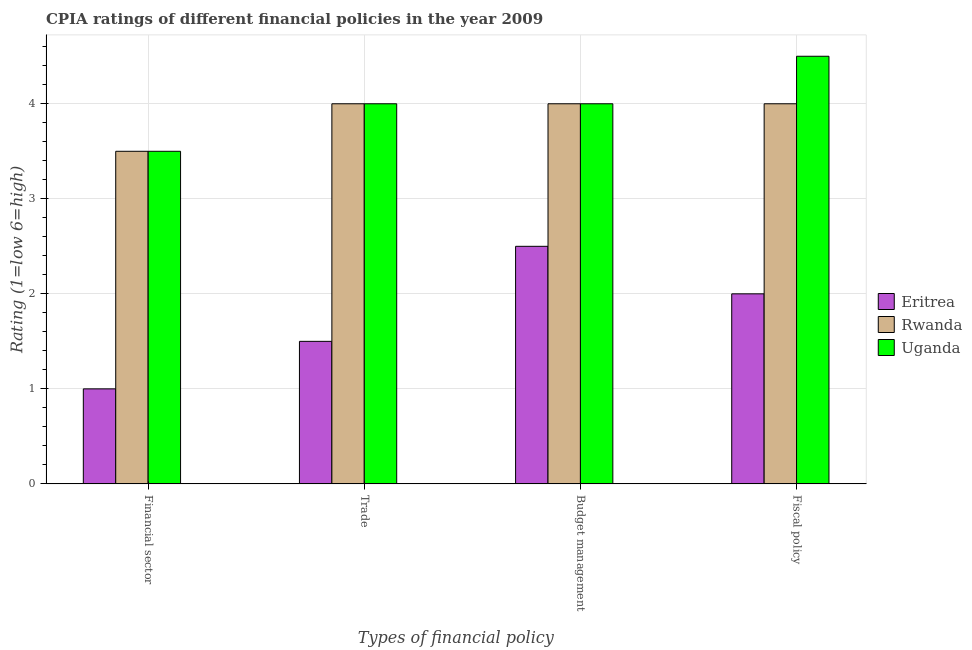How many groups of bars are there?
Give a very brief answer. 4. How many bars are there on the 2nd tick from the left?
Give a very brief answer. 3. What is the label of the 4th group of bars from the left?
Ensure brevity in your answer.  Fiscal policy. Across all countries, what is the maximum cpia rating of budget management?
Give a very brief answer. 4. Across all countries, what is the minimum cpia rating of fiscal policy?
Offer a very short reply. 2. In which country was the cpia rating of trade maximum?
Your response must be concise. Rwanda. In which country was the cpia rating of budget management minimum?
Provide a succinct answer. Eritrea. What is the total cpia rating of trade in the graph?
Provide a succinct answer. 9.5. What is the difference between the cpia rating of budget management in Eritrea and that in Uganda?
Your answer should be compact. -1.5. What is the average cpia rating of financial sector per country?
Your response must be concise. 2.67. In how many countries, is the cpia rating of financial sector greater than 1 ?
Give a very brief answer. 2. What is the ratio of the cpia rating of fiscal policy in Rwanda to that in Uganda?
Offer a terse response. 0.89. Is the cpia rating of budget management in Uganda less than that in Rwanda?
Make the answer very short. No. Is the difference between the cpia rating of budget management in Rwanda and Uganda greater than the difference between the cpia rating of fiscal policy in Rwanda and Uganda?
Ensure brevity in your answer.  Yes. What does the 1st bar from the left in Trade represents?
Your response must be concise. Eritrea. What does the 3rd bar from the right in Trade represents?
Provide a succinct answer. Eritrea. Is it the case that in every country, the sum of the cpia rating of financial sector and cpia rating of trade is greater than the cpia rating of budget management?
Offer a very short reply. No. How many bars are there?
Your answer should be compact. 12. How many countries are there in the graph?
Make the answer very short. 3. What is the difference between two consecutive major ticks on the Y-axis?
Offer a terse response. 1. Are the values on the major ticks of Y-axis written in scientific E-notation?
Make the answer very short. No. Does the graph contain grids?
Provide a short and direct response. Yes. How many legend labels are there?
Keep it short and to the point. 3. How are the legend labels stacked?
Give a very brief answer. Vertical. What is the title of the graph?
Ensure brevity in your answer.  CPIA ratings of different financial policies in the year 2009. What is the label or title of the X-axis?
Make the answer very short. Types of financial policy. What is the Rating (1=low 6=high) of Eritrea in Financial sector?
Offer a terse response. 1. What is the Rating (1=low 6=high) of Uganda in Trade?
Offer a very short reply. 4. What is the Rating (1=low 6=high) of Eritrea in Budget management?
Provide a short and direct response. 2.5. What is the Rating (1=low 6=high) of Uganda in Budget management?
Keep it short and to the point. 4. What is the Rating (1=low 6=high) of Eritrea in Fiscal policy?
Your answer should be compact. 2. What is the Rating (1=low 6=high) in Uganda in Fiscal policy?
Offer a terse response. 4.5. Across all Types of financial policy, what is the maximum Rating (1=low 6=high) in Rwanda?
Give a very brief answer. 4. Across all Types of financial policy, what is the minimum Rating (1=low 6=high) in Uganda?
Your answer should be compact. 3.5. What is the total Rating (1=low 6=high) of Eritrea in the graph?
Keep it short and to the point. 7. What is the total Rating (1=low 6=high) of Rwanda in the graph?
Offer a very short reply. 15.5. What is the total Rating (1=low 6=high) in Uganda in the graph?
Your answer should be very brief. 16. What is the difference between the Rating (1=low 6=high) in Eritrea in Financial sector and that in Trade?
Your answer should be compact. -0.5. What is the difference between the Rating (1=low 6=high) of Uganda in Financial sector and that in Trade?
Provide a succinct answer. -0.5. What is the difference between the Rating (1=low 6=high) of Uganda in Financial sector and that in Budget management?
Provide a short and direct response. -0.5. What is the difference between the Rating (1=low 6=high) of Rwanda in Financial sector and that in Fiscal policy?
Provide a succinct answer. -0.5. What is the difference between the Rating (1=low 6=high) in Uganda in Financial sector and that in Fiscal policy?
Your response must be concise. -1. What is the difference between the Rating (1=low 6=high) of Eritrea in Trade and that in Budget management?
Offer a terse response. -1. What is the difference between the Rating (1=low 6=high) in Uganda in Trade and that in Budget management?
Make the answer very short. 0. What is the difference between the Rating (1=low 6=high) of Eritrea in Trade and that in Fiscal policy?
Your response must be concise. -0.5. What is the difference between the Rating (1=low 6=high) in Rwanda in Trade and that in Fiscal policy?
Make the answer very short. 0. What is the difference between the Rating (1=low 6=high) of Uganda in Budget management and that in Fiscal policy?
Give a very brief answer. -0.5. What is the difference between the Rating (1=low 6=high) in Eritrea in Financial sector and the Rating (1=low 6=high) in Uganda in Trade?
Your answer should be very brief. -3. What is the difference between the Rating (1=low 6=high) of Rwanda in Financial sector and the Rating (1=low 6=high) of Uganda in Trade?
Provide a succinct answer. -0.5. What is the difference between the Rating (1=low 6=high) of Eritrea in Financial sector and the Rating (1=low 6=high) of Rwanda in Budget management?
Provide a short and direct response. -3. What is the difference between the Rating (1=low 6=high) in Rwanda in Financial sector and the Rating (1=low 6=high) in Uganda in Budget management?
Your answer should be very brief. -0.5. What is the difference between the Rating (1=low 6=high) of Eritrea in Trade and the Rating (1=low 6=high) of Rwanda in Budget management?
Your answer should be compact. -2.5. What is the difference between the Rating (1=low 6=high) in Eritrea in Trade and the Rating (1=low 6=high) in Uganda in Budget management?
Give a very brief answer. -2.5. What is the difference between the Rating (1=low 6=high) of Eritrea in Trade and the Rating (1=low 6=high) of Rwanda in Fiscal policy?
Offer a very short reply. -2.5. What is the average Rating (1=low 6=high) in Eritrea per Types of financial policy?
Your answer should be compact. 1.75. What is the average Rating (1=low 6=high) of Rwanda per Types of financial policy?
Keep it short and to the point. 3.88. What is the average Rating (1=low 6=high) in Uganda per Types of financial policy?
Make the answer very short. 4. What is the difference between the Rating (1=low 6=high) in Rwanda and Rating (1=low 6=high) in Uganda in Financial sector?
Offer a terse response. 0. What is the difference between the Rating (1=low 6=high) of Eritrea and Rating (1=low 6=high) of Uganda in Trade?
Your answer should be compact. -2.5. What is the difference between the Rating (1=low 6=high) of Rwanda and Rating (1=low 6=high) of Uganda in Trade?
Offer a terse response. 0. What is the difference between the Rating (1=low 6=high) in Eritrea and Rating (1=low 6=high) in Rwanda in Budget management?
Your answer should be very brief. -1.5. What is the difference between the Rating (1=low 6=high) in Rwanda and Rating (1=low 6=high) in Uganda in Budget management?
Offer a terse response. 0. What is the difference between the Rating (1=low 6=high) in Eritrea and Rating (1=low 6=high) in Rwanda in Fiscal policy?
Make the answer very short. -2. What is the difference between the Rating (1=low 6=high) of Eritrea and Rating (1=low 6=high) of Uganda in Fiscal policy?
Give a very brief answer. -2.5. What is the ratio of the Rating (1=low 6=high) of Rwanda in Financial sector to that in Budget management?
Ensure brevity in your answer.  0.88. What is the ratio of the Rating (1=low 6=high) of Uganda in Financial sector to that in Budget management?
Make the answer very short. 0.88. What is the ratio of the Rating (1=low 6=high) of Eritrea in Trade to that in Budget management?
Your answer should be very brief. 0.6. What is the ratio of the Rating (1=low 6=high) in Rwanda in Trade to that in Budget management?
Make the answer very short. 1. What is the ratio of the Rating (1=low 6=high) of Uganda in Trade to that in Budget management?
Offer a terse response. 1. What is the ratio of the Rating (1=low 6=high) of Eritrea in Trade to that in Fiscal policy?
Provide a succinct answer. 0.75. What is the ratio of the Rating (1=low 6=high) of Rwanda in Trade to that in Fiscal policy?
Your answer should be very brief. 1. What is the ratio of the Rating (1=low 6=high) in Eritrea in Budget management to that in Fiscal policy?
Ensure brevity in your answer.  1.25. What is the ratio of the Rating (1=low 6=high) in Rwanda in Budget management to that in Fiscal policy?
Give a very brief answer. 1. What is the difference between the highest and the lowest Rating (1=low 6=high) in Eritrea?
Provide a short and direct response. 1.5. What is the difference between the highest and the lowest Rating (1=low 6=high) in Rwanda?
Offer a terse response. 0.5. What is the difference between the highest and the lowest Rating (1=low 6=high) of Uganda?
Provide a short and direct response. 1. 